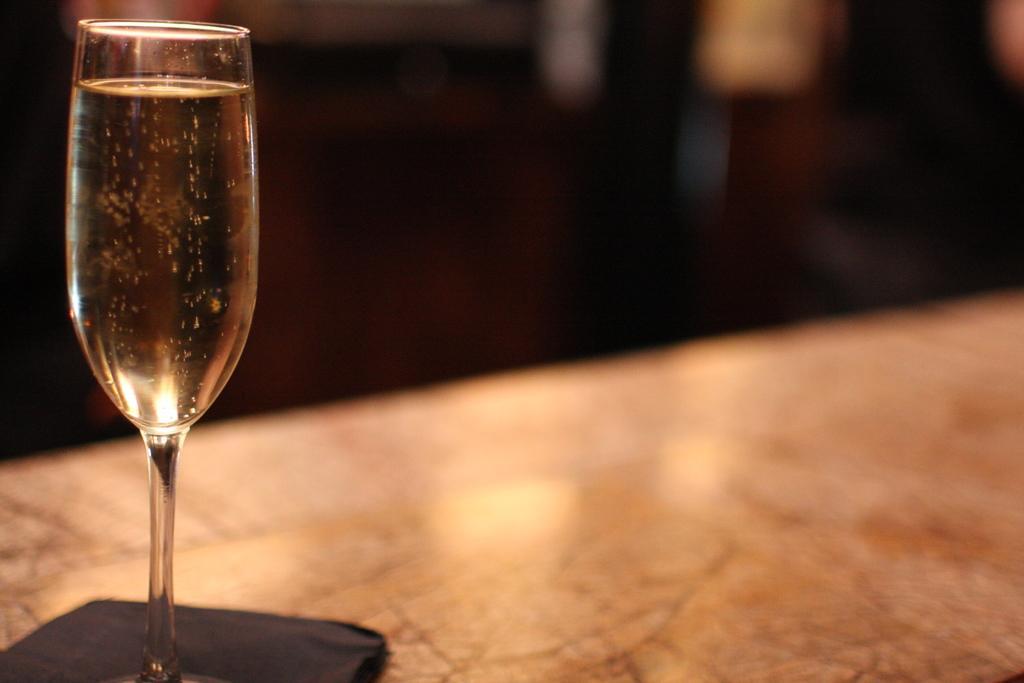Can you describe this image briefly? In this image I can see on the left side there is the wine glass. 